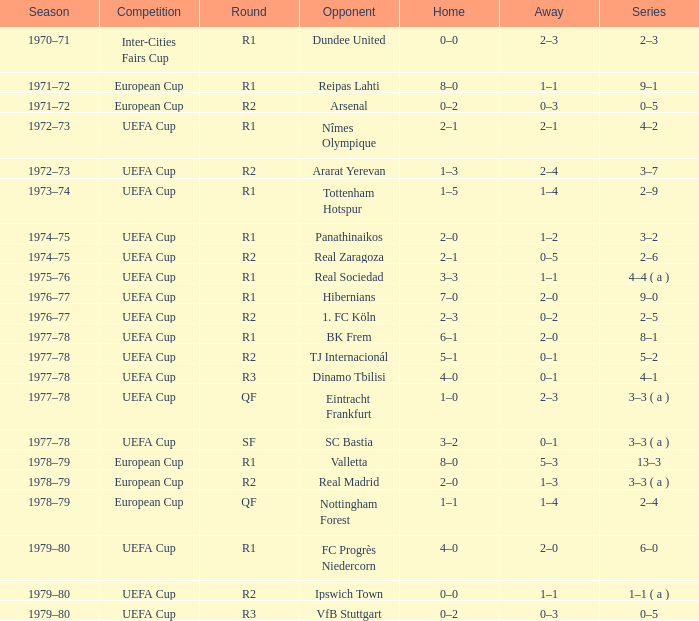At which phase is there a uefa cup competition and a 5-2 series? R2. 